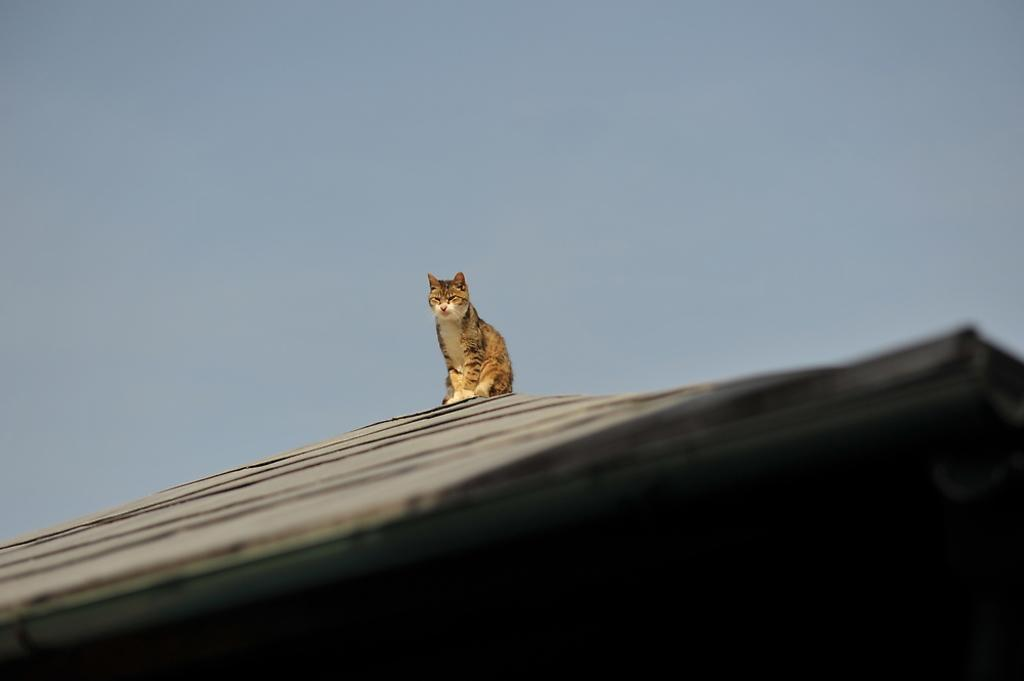What animal is present in the image? There is a cat in the image. Where is the cat located? The cat is sitting on the top of a house roof. What can be seen in the background of the image? The sky is visible in the background of the image. What type of railway can be seen in the image? There is no railway present in the image; it features a cat sitting on a house roof with a visible sky in the background. 